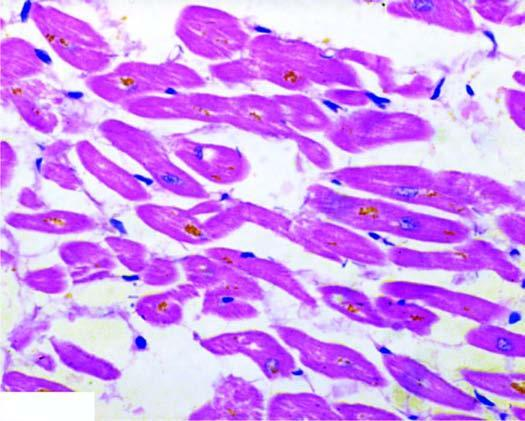re the lipofuscin pigment granules seen in the cytoplasm of the myocardial fibres, especially around the nuclei?
Answer the question using a single word or phrase. Yes 